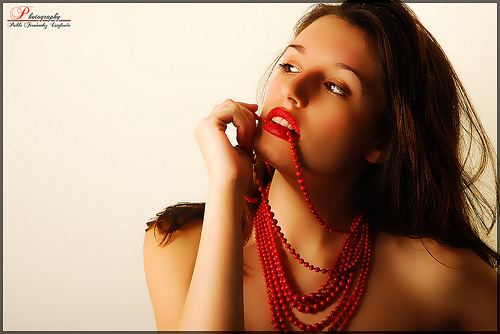<image>
Is the woman on the background? No. The woman is not positioned on the background. They may be near each other, but the woman is not supported by or resting on top of the background. Where is the necklace in relation to the teeth? Is it behind the teeth? Yes. From this viewpoint, the necklace is positioned behind the teeth, with the teeth partially or fully occluding the necklace. 